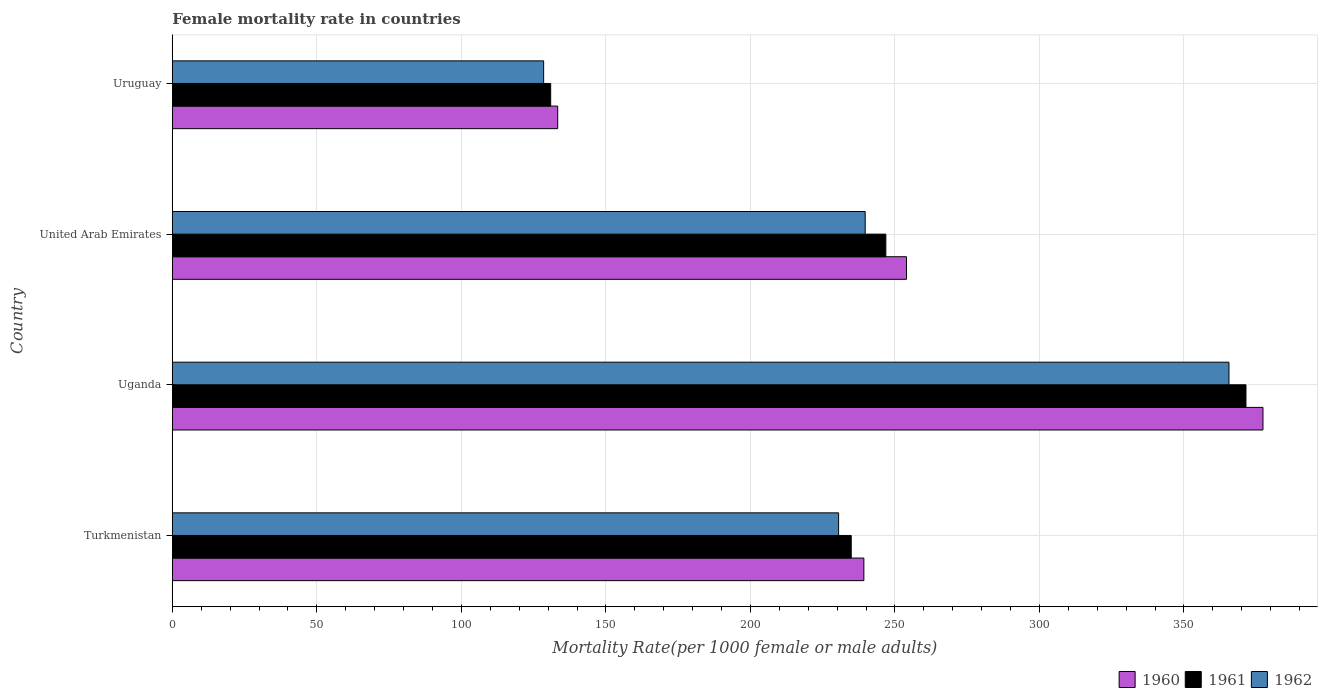How many different coloured bars are there?
Your response must be concise. 3. How many groups of bars are there?
Give a very brief answer. 4. Are the number of bars on each tick of the Y-axis equal?
Provide a short and direct response. Yes. How many bars are there on the 1st tick from the bottom?
Offer a terse response. 3. What is the label of the 1st group of bars from the top?
Keep it short and to the point. Uruguay. What is the female mortality rate in 1960 in Turkmenistan?
Keep it short and to the point. 239.24. Across all countries, what is the maximum female mortality rate in 1961?
Make the answer very short. 371.44. Across all countries, what is the minimum female mortality rate in 1962?
Provide a succinct answer. 128.46. In which country was the female mortality rate in 1961 maximum?
Offer a terse response. Uganda. In which country was the female mortality rate in 1961 minimum?
Your response must be concise. Uruguay. What is the total female mortality rate in 1962 in the graph?
Offer a terse response. 964.23. What is the difference between the female mortality rate in 1960 in Turkmenistan and that in Uganda?
Your answer should be compact. -138.08. What is the difference between the female mortality rate in 1961 in Uganda and the female mortality rate in 1962 in Turkmenistan?
Keep it short and to the point. 140.94. What is the average female mortality rate in 1961 per country?
Your answer should be compact. 246.01. What is the difference between the female mortality rate in 1961 and female mortality rate in 1962 in United Arab Emirates?
Your answer should be very brief. 7.15. What is the ratio of the female mortality rate in 1960 in Uganda to that in United Arab Emirates?
Your answer should be compact. 1.49. What is the difference between the highest and the second highest female mortality rate in 1961?
Your answer should be very brief. 124.6. What is the difference between the highest and the lowest female mortality rate in 1960?
Provide a short and direct response. 244. In how many countries, is the female mortality rate in 1962 greater than the average female mortality rate in 1962 taken over all countries?
Provide a succinct answer. 1. Is the sum of the female mortality rate in 1961 in Turkmenistan and Uruguay greater than the maximum female mortality rate in 1960 across all countries?
Provide a short and direct response. No. How many bars are there?
Make the answer very short. 12. Are all the bars in the graph horizontal?
Your answer should be very brief. Yes. What is the difference between two consecutive major ticks on the X-axis?
Give a very brief answer. 50. Are the values on the major ticks of X-axis written in scientific E-notation?
Provide a short and direct response. No. Does the graph contain any zero values?
Provide a short and direct response. No. Does the graph contain grids?
Offer a terse response. Yes. Where does the legend appear in the graph?
Offer a very short reply. Bottom right. How many legend labels are there?
Your answer should be very brief. 3. What is the title of the graph?
Your answer should be compact. Female mortality rate in countries. Does "2015" appear as one of the legend labels in the graph?
Your answer should be very brief. No. What is the label or title of the X-axis?
Provide a succinct answer. Mortality Rate(per 1000 female or male adults). What is the Mortality Rate(per 1000 female or male adults) of 1960 in Turkmenistan?
Give a very brief answer. 239.24. What is the Mortality Rate(per 1000 female or male adults) in 1961 in Turkmenistan?
Ensure brevity in your answer.  234.88. What is the Mortality Rate(per 1000 female or male adults) in 1962 in Turkmenistan?
Give a very brief answer. 230.51. What is the Mortality Rate(per 1000 female or male adults) of 1960 in Uganda?
Make the answer very short. 377.32. What is the Mortality Rate(per 1000 female or male adults) of 1961 in Uganda?
Offer a terse response. 371.44. What is the Mortality Rate(per 1000 female or male adults) of 1962 in Uganda?
Keep it short and to the point. 365.57. What is the Mortality Rate(per 1000 female or male adults) in 1960 in United Arab Emirates?
Offer a terse response. 253.99. What is the Mortality Rate(per 1000 female or male adults) of 1961 in United Arab Emirates?
Offer a very short reply. 246.85. What is the Mortality Rate(per 1000 female or male adults) of 1962 in United Arab Emirates?
Your answer should be compact. 239.7. What is the Mortality Rate(per 1000 female or male adults) in 1960 in Uruguay?
Make the answer very short. 133.32. What is the Mortality Rate(per 1000 female or male adults) of 1961 in Uruguay?
Your answer should be very brief. 130.89. What is the Mortality Rate(per 1000 female or male adults) of 1962 in Uruguay?
Ensure brevity in your answer.  128.46. Across all countries, what is the maximum Mortality Rate(per 1000 female or male adults) of 1960?
Make the answer very short. 377.32. Across all countries, what is the maximum Mortality Rate(per 1000 female or male adults) of 1961?
Keep it short and to the point. 371.44. Across all countries, what is the maximum Mortality Rate(per 1000 female or male adults) of 1962?
Your response must be concise. 365.57. Across all countries, what is the minimum Mortality Rate(per 1000 female or male adults) in 1960?
Keep it short and to the point. 133.32. Across all countries, what is the minimum Mortality Rate(per 1000 female or male adults) of 1961?
Provide a short and direct response. 130.89. Across all countries, what is the minimum Mortality Rate(per 1000 female or male adults) of 1962?
Your answer should be very brief. 128.46. What is the total Mortality Rate(per 1000 female or male adults) in 1960 in the graph?
Your answer should be very brief. 1003.88. What is the total Mortality Rate(per 1000 female or male adults) of 1961 in the graph?
Ensure brevity in your answer.  984.06. What is the total Mortality Rate(per 1000 female or male adults) of 1962 in the graph?
Make the answer very short. 964.23. What is the difference between the Mortality Rate(per 1000 female or male adults) of 1960 in Turkmenistan and that in Uganda?
Ensure brevity in your answer.  -138.08. What is the difference between the Mortality Rate(per 1000 female or male adults) in 1961 in Turkmenistan and that in Uganda?
Give a very brief answer. -136.57. What is the difference between the Mortality Rate(per 1000 female or male adults) of 1962 in Turkmenistan and that in Uganda?
Ensure brevity in your answer.  -135.06. What is the difference between the Mortality Rate(per 1000 female or male adults) in 1960 in Turkmenistan and that in United Arab Emirates?
Make the answer very short. -14.75. What is the difference between the Mortality Rate(per 1000 female or male adults) in 1961 in Turkmenistan and that in United Arab Emirates?
Make the answer very short. -11.97. What is the difference between the Mortality Rate(per 1000 female or male adults) of 1962 in Turkmenistan and that in United Arab Emirates?
Ensure brevity in your answer.  -9.19. What is the difference between the Mortality Rate(per 1000 female or male adults) in 1960 in Turkmenistan and that in Uruguay?
Make the answer very short. 105.92. What is the difference between the Mortality Rate(per 1000 female or male adults) of 1961 in Turkmenistan and that in Uruguay?
Your answer should be compact. 103.99. What is the difference between the Mortality Rate(per 1000 female or male adults) in 1962 in Turkmenistan and that in Uruguay?
Make the answer very short. 102.05. What is the difference between the Mortality Rate(per 1000 female or male adults) of 1960 in Uganda and that in United Arab Emirates?
Your answer should be compact. 123.33. What is the difference between the Mortality Rate(per 1000 female or male adults) of 1961 in Uganda and that in United Arab Emirates?
Your answer should be very brief. 124.6. What is the difference between the Mortality Rate(per 1000 female or male adults) in 1962 in Uganda and that in United Arab Emirates?
Your response must be concise. 125.86. What is the difference between the Mortality Rate(per 1000 female or male adults) of 1960 in Uganda and that in Uruguay?
Offer a very short reply. 244. What is the difference between the Mortality Rate(per 1000 female or male adults) of 1961 in Uganda and that in Uruguay?
Offer a very short reply. 240.56. What is the difference between the Mortality Rate(per 1000 female or male adults) in 1962 in Uganda and that in Uruguay?
Provide a succinct answer. 237.11. What is the difference between the Mortality Rate(per 1000 female or male adults) of 1960 in United Arab Emirates and that in Uruguay?
Provide a succinct answer. 120.67. What is the difference between the Mortality Rate(per 1000 female or male adults) of 1961 in United Arab Emirates and that in Uruguay?
Provide a short and direct response. 115.96. What is the difference between the Mortality Rate(per 1000 female or male adults) in 1962 in United Arab Emirates and that in Uruguay?
Your answer should be compact. 111.25. What is the difference between the Mortality Rate(per 1000 female or male adults) of 1960 in Turkmenistan and the Mortality Rate(per 1000 female or male adults) of 1961 in Uganda?
Keep it short and to the point. -132.2. What is the difference between the Mortality Rate(per 1000 female or male adults) of 1960 in Turkmenistan and the Mortality Rate(per 1000 female or male adults) of 1962 in Uganda?
Your answer should be compact. -126.32. What is the difference between the Mortality Rate(per 1000 female or male adults) in 1961 in Turkmenistan and the Mortality Rate(per 1000 female or male adults) in 1962 in Uganda?
Provide a succinct answer. -130.69. What is the difference between the Mortality Rate(per 1000 female or male adults) of 1960 in Turkmenistan and the Mortality Rate(per 1000 female or male adults) of 1961 in United Arab Emirates?
Make the answer very short. -7.61. What is the difference between the Mortality Rate(per 1000 female or male adults) of 1960 in Turkmenistan and the Mortality Rate(per 1000 female or male adults) of 1962 in United Arab Emirates?
Ensure brevity in your answer.  -0.46. What is the difference between the Mortality Rate(per 1000 female or male adults) of 1961 in Turkmenistan and the Mortality Rate(per 1000 female or male adults) of 1962 in United Arab Emirates?
Your answer should be compact. -4.83. What is the difference between the Mortality Rate(per 1000 female or male adults) of 1960 in Turkmenistan and the Mortality Rate(per 1000 female or male adults) of 1961 in Uruguay?
Your response must be concise. 108.36. What is the difference between the Mortality Rate(per 1000 female or male adults) in 1960 in Turkmenistan and the Mortality Rate(per 1000 female or male adults) in 1962 in Uruguay?
Offer a very short reply. 110.79. What is the difference between the Mortality Rate(per 1000 female or male adults) in 1961 in Turkmenistan and the Mortality Rate(per 1000 female or male adults) in 1962 in Uruguay?
Provide a succinct answer. 106.42. What is the difference between the Mortality Rate(per 1000 female or male adults) in 1960 in Uganda and the Mortality Rate(per 1000 female or male adults) in 1961 in United Arab Emirates?
Keep it short and to the point. 130.47. What is the difference between the Mortality Rate(per 1000 female or male adults) of 1960 in Uganda and the Mortality Rate(per 1000 female or male adults) of 1962 in United Arab Emirates?
Ensure brevity in your answer.  137.62. What is the difference between the Mortality Rate(per 1000 female or male adults) of 1961 in Uganda and the Mortality Rate(per 1000 female or male adults) of 1962 in United Arab Emirates?
Provide a short and direct response. 131.74. What is the difference between the Mortality Rate(per 1000 female or male adults) in 1960 in Uganda and the Mortality Rate(per 1000 female or male adults) in 1961 in Uruguay?
Provide a short and direct response. 246.44. What is the difference between the Mortality Rate(per 1000 female or male adults) in 1960 in Uganda and the Mortality Rate(per 1000 female or male adults) in 1962 in Uruguay?
Your response must be concise. 248.87. What is the difference between the Mortality Rate(per 1000 female or male adults) in 1961 in Uganda and the Mortality Rate(per 1000 female or male adults) in 1962 in Uruguay?
Provide a short and direct response. 242.99. What is the difference between the Mortality Rate(per 1000 female or male adults) in 1960 in United Arab Emirates and the Mortality Rate(per 1000 female or male adults) in 1961 in Uruguay?
Your answer should be compact. 123.11. What is the difference between the Mortality Rate(per 1000 female or male adults) in 1960 in United Arab Emirates and the Mortality Rate(per 1000 female or male adults) in 1962 in Uruguay?
Offer a very short reply. 125.54. What is the difference between the Mortality Rate(per 1000 female or male adults) in 1961 in United Arab Emirates and the Mortality Rate(per 1000 female or male adults) in 1962 in Uruguay?
Make the answer very short. 118.39. What is the average Mortality Rate(per 1000 female or male adults) in 1960 per country?
Your answer should be compact. 250.97. What is the average Mortality Rate(per 1000 female or male adults) in 1961 per country?
Give a very brief answer. 246.01. What is the average Mortality Rate(per 1000 female or male adults) of 1962 per country?
Give a very brief answer. 241.06. What is the difference between the Mortality Rate(per 1000 female or male adults) of 1960 and Mortality Rate(per 1000 female or male adults) of 1961 in Turkmenistan?
Offer a very short reply. 4.37. What is the difference between the Mortality Rate(per 1000 female or male adults) in 1960 and Mortality Rate(per 1000 female or male adults) in 1962 in Turkmenistan?
Offer a very short reply. 8.73. What is the difference between the Mortality Rate(per 1000 female or male adults) in 1961 and Mortality Rate(per 1000 female or male adults) in 1962 in Turkmenistan?
Your answer should be compact. 4.37. What is the difference between the Mortality Rate(per 1000 female or male adults) of 1960 and Mortality Rate(per 1000 female or male adults) of 1961 in Uganda?
Offer a very short reply. 5.88. What is the difference between the Mortality Rate(per 1000 female or male adults) in 1960 and Mortality Rate(per 1000 female or male adults) in 1962 in Uganda?
Your answer should be compact. 11.76. What is the difference between the Mortality Rate(per 1000 female or male adults) in 1961 and Mortality Rate(per 1000 female or male adults) in 1962 in Uganda?
Offer a terse response. 5.88. What is the difference between the Mortality Rate(per 1000 female or male adults) in 1960 and Mortality Rate(per 1000 female or male adults) in 1961 in United Arab Emirates?
Keep it short and to the point. 7.14. What is the difference between the Mortality Rate(per 1000 female or male adults) of 1960 and Mortality Rate(per 1000 female or male adults) of 1962 in United Arab Emirates?
Your response must be concise. 14.29. What is the difference between the Mortality Rate(per 1000 female or male adults) in 1961 and Mortality Rate(per 1000 female or male adults) in 1962 in United Arab Emirates?
Your answer should be compact. 7.15. What is the difference between the Mortality Rate(per 1000 female or male adults) in 1960 and Mortality Rate(per 1000 female or male adults) in 1961 in Uruguay?
Your response must be concise. 2.43. What is the difference between the Mortality Rate(per 1000 female or male adults) of 1960 and Mortality Rate(per 1000 female or male adults) of 1962 in Uruguay?
Give a very brief answer. 4.87. What is the difference between the Mortality Rate(per 1000 female or male adults) in 1961 and Mortality Rate(per 1000 female or male adults) in 1962 in Uruguay?
Give a very brief answer. 2.43. What is the ratio of the Mortality Rate(per 1000 female or male adults) of 1960 in Turkmenistan to that in Uganda?
Ensure brevity in your answer.  0.63. What is the ratio of the Mortality Rate(per 1000 female or male adults) in 1961 in Turkmenistan to that in Uganda?
Ensure brevity in your answer.  0.63. What is the ratio of the Mortality Rate(per 1000 female or male adults) in 1962 in Turkmenistan to that in Uganda?
Make the answer very short. 0.63. What is the ratio of the Mortality Rate(per 1000 female or male adults) of 1960 in Turkmenistan to that in United Arab Emirates?
Your answer should be very brief. 0.94. What is the ratio of the Mortality Rate(per 1000 female or male adults) of 1961 in Turkmenistan to that in United Arab Emirates?
Give a very brief answer. 0.95. What is the ratio of the Mortality Rate(per 1000 female or male adults) in 1962 in Turkmenistan to that in United Arab Emirates?
Your response must be concise. 0.96. What is the ratio of the Mortality Rate(per 1000 female or male adults) in 1960 in Turkmenistan to that in Uruguay?
Provide a succinct answer. 1.79. What is the ratio of the Mortality Rate(per 1000 female or male adults) of 1961 in Turkmenistan to that in Uruguay?
Keep it short and to the point. 1.79. What is the ratio of the Mortality Rate(per 1000 female or male adults) of 1962 in Turkmenistan to that in Uruguay?
Give a very brief answer. 1.79. What is the ratio of the Mortality Rate(per 1000 female or male adults) of 1960 in Uganda to that in United Arab Emirates?
Your answer should be compact. 1.49. What is the ratio of the Mortality Rate(per 1000 female or male adults) of 1961 in Uganda to that in United Arab Emirates?
Keep it short and to the point. 1.5. What is the ratio of the Mortality Rate(per 1000 female or male adults) in 1962 in Uganda to that in United Arab Emirates?
Your answer should be very brief. 1.53. What is the ratio of the Mortality Rate(per 1000 female or male adults) in 1960 in Uganda to that in Uruguay?
Your answer should be very brief. 2.83. What is the ratio of the Mortality Rate(per 1000 female or male adults) in 1961 in Uganda to that in Uruguay?
Provide a succinct answer. 2.84. What is the ratio of the Mortality Rate(per 1000 female or male adults) in 1962 in Uganda to that in Uruguay?
Ensure brevity in your answer.  2.85. What is the ratio of the Mortality Rate(per 1000 female or male adults) in 1960 in United Arab Emirates to that in Uruguay?
Your response must be concise. 1.91. What is the ratio of the Mortality Rate(per 1000 female or male adults) in 1961 in United Arab Emirates to that in Uruguay?
Your answer should be compact. 1.89. What is the ratio of the Mortality Rate(per 1000 female or male adults) of 1962 in United Arab Emirates to that in Uruguay?
Provide a short and direct response. 1.87. What is the difference between the highest and the second highest Mortality Rate(per 1000 female or male adults) in 1960?
Offer a very short reply. 123.33. What is the difference between the highest and the second highest Mortality Rate(per 1000 female or male adults) in 1961?
Keep it short and to the point. 124.6. What is the difference between the highest and the second highest Mortality Rate(per 1000 female or male adults) in 1962?
Your answer should be compact. 125.86. What is the difference between the highest and the lowest Mortality Rate(per 1000 female or male adults) in 1960?
Offer a very short reply. 244. What is the difference between the highest and the lowest Mortality Rate(per 1000 female or male adults) of 1961?
Offer a terse response. 240.56. What is the difference between the highest and the lowest Mortality Rate(per 1000 female or male adults) in 1962?
Provide a short and direct response. 237.11. 